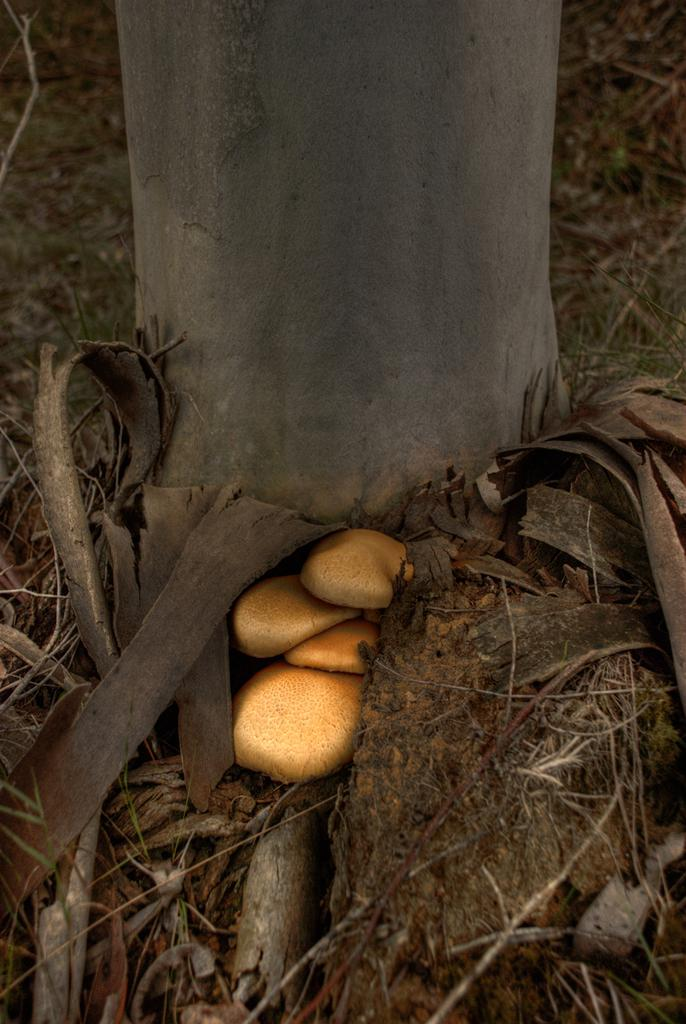What part of a tree can be seen in the image? The image contains the trunk of a tree. What type of fungi is present in the image? There are mushrooms in the image. What can be seen beneath the tree trunk and mushrooms? The ground is visible in the image. What is the condition of the vegetation on the ground? Dried grass is present on the ground. What else can be found on the ground in the image? Pieces of wood are on the ground. What type of lettuce is growing on the tree trunk in the image? There is no lettuce present in the image; it features the trunk of a tree and mushrooms. What type of fiction is being read by the mushrooms in the image? There is no fiction or reading activity depicted in the image; it only shows the trunk of a tree, mushrooms, the ground, dried grass, and pieces of wood. 